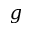Convert formula to latex. <formula><loc_0><loc_0><loc_500><loc_500>g</formula> 